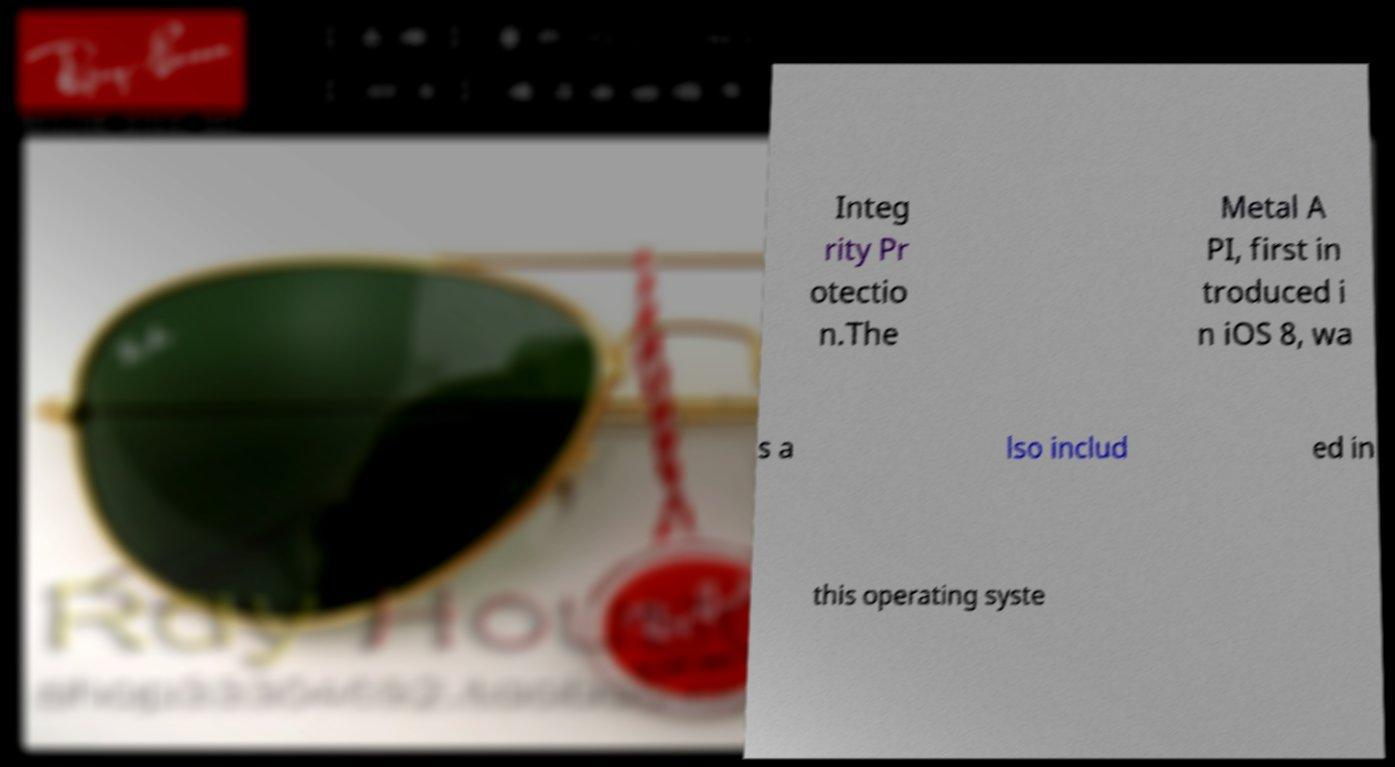There's text embedded in this image that I need extracted. Can you transcribe it verbatim? Integ rity Pr otectio n.The Metal A PI, first in troduced i n iOS 8, wa s a lso includ ed in this operating syste 